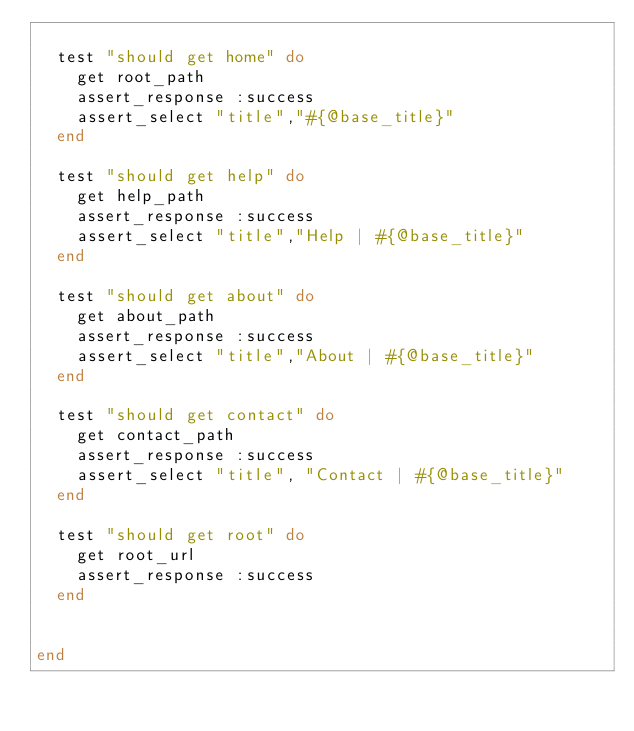<code> <loc_0><loc_0><loc_500><loc_500><_Ruby_>
  test "should get home" do
    get root_path
    assert_response :success
    assert_select "title","#{@base_title}"
  end

  test "should get help" do
    get help_path
    assert_response :success
    assert_select "title","Help | #{@base_title}"
  end

  test "should get about" do
    get about_path
    assert_response :success
    assert_select "title","About | #{@base_title}"
  end

  test "should get contact" do
    get contact_path
    assert_response :success
    assert_select "title", "Contact | #{@base_title}"
  end

  test "should get root" do
    get root_url
    assert_response :success
  end


end
</code> 